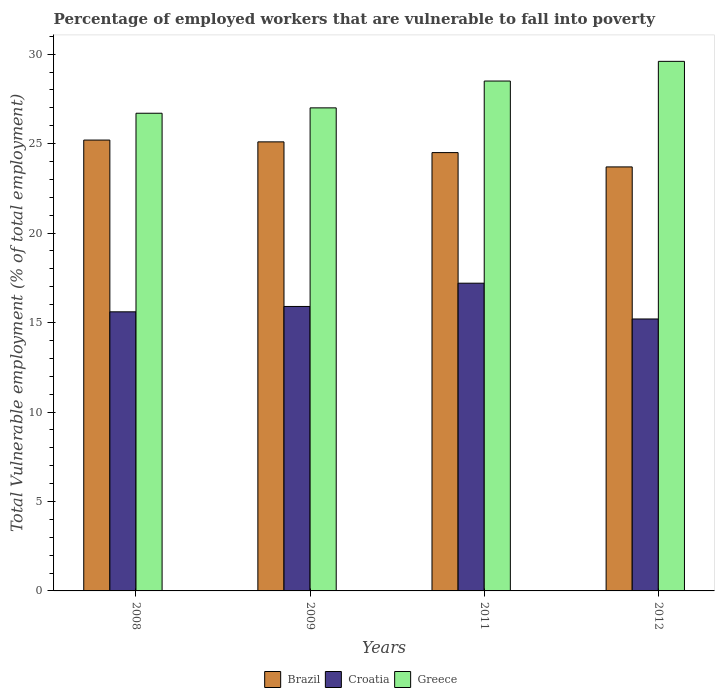How many different coloured bars are there?
Your answer should be very brief. 3. How many groups of bars are there?
Give a very brief answer. 4. How many bars are there on the 4th tick from the left?
Offer a terse response. 3. In how many cases, is the number of bars for a given year not equal to the number of legend labels?
Your answer should be compact. 0. What is the percentage of employed workers who are vulnerable to fall into poverty in Brazil in 2009?
Give a very brief answer. 25.1. Across all years, what is the maximum percentage of employed workers who are vulnerable to fall into poverty in Brazil?
Ensure brevity in your answer.  25.2. Across all years, what is the minimum percentage of employed workers who are vulnerable to fall into poverty in Greece?
Your answer should be very brief. 26.7. In which year was the percentage of employed workers who are vulnerable to fall into poverty in Greece maximum?
Ensure brevity in your answer.  2012. In which year was the percentage of employed workers who are vulnerable to fall into poverty in Croatia minimum?
Offer a very short reply. 2012. What is the total percentage of employed workers who are vulnerable to fall into poverty in Brazil in the graph?
Ensure brevity in your answer.  98.5. What is the difference between the percentage of employed workers who are vulnerable to fall into poverty in Greece in 2011 and that in 2012?
Your response must be concise. -1.1. What is the average percentage of employed workers who are vulnerable to fall into poverty in Croatia per year?
Your response must be concise. 15.98. In the year 2012, what is the difference between the percentage of employed workers who are vulnerable to fall into poverty in Brazil and percentage of employed workers who are vulnerable to fall into poverty in Croatia?
Your answer should be compact. 8.5. What is the ratio of the percentage of employed workers who are vulnerable to fall into poverty in Brazil in 2011 to that in 2012?
Make the answer very short. 1.03. What is the difference between the highest and the second highest percentage of employed workers who are vulnerable to fall into poverty in Brazil?
Provide a succinct answer. 0.1. What is the difference between the highest and the lowest percentage of employed workers who are vulnerable to fall into poverty in Croatia?
Offer a very short reply. 2. In how many years, is the percentage of employed workers who are vulnerable to fall into poverty in Greece greater than the average percentage of employed workers who are vulnerable to fall into poverty in Greece taken over all years?
Provide a succinct answer. 2. Is the sum of the percentage of employed workers who are vulnerable to fall into poverty in Croatia in 2008 and 2012 greater than the maximum percentage of employed workers who are vulnerable to fall into poverty in Brazil across all years?
Offer a terse response. Yes. What does the 1st bar from the left in 2008 represents?
Keep it short and to the point. Brazil. What does the 2nd bar from the right in 2008 represents?
Give a very brief answer. Croatia. Is it the case that in every year, the sum of the percentage of employed workers who are vulnerable to fall into poverty in Greece and percentage of employed workers who are vulnerable to fall into poverty in Brazil is greater than the percentage of employed workers who are vulnerable to fall into poverty in Croatia?
Provide a short and direct response. Yes. How many bars are there?
Make the answer very short. 12. How many years are there in the graph?
Give a very brief answer. 4. How many legend labels are there?
Provide a succinct answer. 3. What is the title of the graph?
Keep it short and to the point. Percentage of employed workers that are vulnerable to fall into poverty. Does "Morocco" appear as one of the legend labels in the graph?
Your response must be concise. No. What is the label or title of the X-axis?
Offer a terse response. Years. What is the label or title of the Y-axis?
Your answer should be very brief. Total Vulnerable employment (% of total employment). What is the Total Vulnerable employment (% of total employment) in Brazil in 2008?
Keep it short and to the point. 25.2. What is the Total Vulnerable employment (% of total employment) in Croatia in 2008?
Ensure brevity in your answer.  15.6. What is the Total Vulnerable employment (% of total employment) in Greece in 2008?
Provide a succinct answer. 26.7. What is the Total Vulnerable employment (% of total employment) of Brazil in 2009?
Keep it short and to the point. 25.1. What is the Total Vulnerable employment (% of total employment) of Croatia in 2009?
Offer a terse response. 15.9. What is the Total Vulnerable employment (% of total employment) of Greece in 2009?
Give a very brief answer. 27. What is the Total Vulnerable employment (% of total employment) of Croatia in 2011?
Your answer should be very brief. 17.2. What is the Total Vulnerable employment (% of total employment) in Brazil in 2012?
Your answer should be compact. 23.7. What is the Total Vulnerable employment (% of total employment) of Croatia in 2012?
Your response must be concise. 15.2. What is the Total Vulnerable employment (% of total employment) of Greece in 2012?
Offer a very short reply. 29.6. Across all years, what is the maximum Total Vulnerable employment (% of total employment) of Brazil?
Provide a short and direct response. 25.2. Across all years, what is the maximum Total Vulnerable employment (% of total employment) of Croatia?
Your answer should be compact. 17.2. Across all years, what is the maximum Total Vulnerable employment (% of total employment) of Greece?
Give a very brief answer. 29.6. Across all years, what is the minimum Total Vulnerable employment (% of total employment) of Brazil?
Provide a succinct answer. 23.7. Across all years, what is the minimum Total Vulnerable employment (% of total employment) of Croatia?
Your response must be concise. 15.2. Across all years, what is the minimum Total Vulnerable employment (% of total employment) in Greece?
Offer a very short reply. 26.7. What is the total Total Vulnerable employment (% of total employment) of Brazil in the graph?
Offer a terse response. 98.5. What is the total Total Vulnerable employment (% of total employment) of Croatia in the graph?
Provide a succinct answer. 63.9. What is the total Total Vulnerable employment (% of total employment) of Greece in the graph?
Offer a very short reply. 111.8. What is the difference between the Total Vulnerable employment (% of total employment) of Croatia in 2008 and that in 2009?
Provide a short and direct response. -0.3. What is the difference between the Total Vulnerable employment (% of total employment) of Greece in 2008 and that in 2009?
Give a very brief answer. -0.3. What is the difference between the Total Vulnerable employment (% of total employment) of Brazil in 2008 and that in 2011?
Your answer should be compact. 0.7. What is the difference between the Total Vulnerable employment (% of total employment) in Greece in 2008 and that in 2011?
Provide a short and direct response. -1.8. What is the difference between the Total Vulnerable employment (% of total employment) of Croatia in 2008 and that in 2012?
Keep it short and to the point. 0.4. What is the difference between the Total Vulnerable employment (% of total employment) of Brazil in 2009 and that in 2012?
Provide a succinct answer. 1.4. What is the difference between the Total Vulnerable employment (% of total employment) of Greece in 2011 and that in 2012?
Your answer should be compact. -1.1. What is the difference between the Total Vulnerable employment (% of total employment) in Brazil in 2008 and the Total Vulnerable employment (% of total employment) in Croatia in 2009?
Your answer should be compact. 9.3. What is the difference between the Total Vulnerable employment (% of total employment) of Croatia in 2008 and the Total Vulnerable employment (% of total employment) of Greece in 2009?
Provide a succinct answer. -11.4. What is the difference between the Total Vulnerable employment (% of total employment) of Brazil in 2008 and the Total Vulnerable employment (% of total employment) of Croatia in 2011?
Provide a short and direct response. 8. What is the difference between the Total Vulnerable employment (% of total employment) of Brazil in 2008 and the Total Vulnerable employment (% of total employment) of Greece in 2011?
Provide a short and direct response. -3.3. What is the difference between the Total Vulnerable employment (% of total employment) in Brazil in 2008 and the Total Vulnerable employment (% of total employment) in Greece in 2012?
Give a very brief answer. -4.4. What is the difference between the Total Vulnerable employment (% of total employment) of Brazil in 2009 and the Total Vulnerable employment (% of total employment) of Greece in 2011?
Offer a terse response. -3.4. What is the difference between the Total Vulnerable employment (% of total employment) of Brazil in 2009 and the Total Vulnerable employment (% of total employment) of Greece in 2012?
Make the answer very short. -4.5. What is the difference between the Total Vulnerable employment (% of total employment) in Croatia in 2009 and the Total Vulnerable employment (% of total employment) in Greece in 2012?
Provide a short and direct response. -13.7. What is the difference between the Total Vulnerable employment (% of total employment) of Brazil in 2011 and the Total Vulnerable employment (% of total employment) of Greece in 2012?
Your response must be concise. -5.1. What is the difference between the Total Vulnerable employment (% of total employment) in Croatia in 2011 and the Total Vulnerable employment (% of total employment) in Greece in 2012?
Your answer should be very brief. -12.4. What is the average Total Vulnerable employment (% of total employment) of Brazil per year?
Offer a terse response. 24.62. What is the average Total Vulnerable employment (% of total employment) of Croatia per year?
Your answer should be very brief. 15.97. What is the average Total Vulnerable employment (% of total employment) of Greece per year?
Your answer should be compact. 27.95. In the year 2008, what is the difference between the Total Vulnerable employment (% of total employment) of Brazil and Total Vulnerable employment (% of total employment) of Croatia?
Provide a short and direct response. 9.6. In the year 2008, what is the difference between the Total Vulnerable employment (% of total employment) in Croatia and Total Vulnerable employment (% of total employment) in Greece?
Make the answer very short. -11.1. In the year 2009, what is the difference between the Total Vulnerable employment (% of total employment) of Brazil and Total Vulnerable employment (% of total employment) of Croatia?
Offer a very short reply. 9.2. In the year 2011, what is the difference between the Total Vulnerable employment (% of total employment) in Brazil and Total Vulnerable employment (% of total employment) in Croatia?
Your response must be concise. 7.3. In the year 2011, what is the difference between the Total Vulnerable employment (% of total employment) of Brazil and Total Vulnerable employment (% of total employment) of Greece?
Your answer should be compact. -4. In the year 2011, what is the difference between the Total Vulnerable employment (% of total employment) of Croatia and Total Vulnerable employment (% of total employment) of Greece?
Make the answer very short. -11.3. In the year 2012, what is the difference between the Total Vulnerable employment (% of total employment) in Brazil and Total Vulnerable employment (% of total employment) in Greece?
Ensure brevity in your answer.  -5.9. In the year 2012, what is the difference between the Total Vulnerable employment (% of total employment) of Croatia and Total Vulnerable employment (% of total employment) of Greece?
Your answer should be compact. -14.4. What is the ratio of the Total Vulnerable employment (% of total employment) in Brazil in 2008 to that in 2009?
Ensure brevity in your answer.  1. What is the ratio of the Total Vulnerable employment (% of total employment) of Croatia in 2008 to that in 2009?
Your answer should be compact. 0.98. What is the ratio of the Total Vulnerable employment (% of total employment) in Greece in 2008 to that in 2009?
Offer a terse response. 0.99. What is the ratio of the Total Vulnerable employment (% of total employment) of Brazil in 2008 to that in 2011?
Offer a terse response. 1.03. What is the ratio of the Total Vulnerable employment (% of total employment) of Croatia in 2008 to that in 2011?
Offer a terse response. 0.91. What is the ratio of the Total Vulnerable employment (% of total employment) of Greece in 2008 to that in 2011?
Make the answer very short. 0.94. What is the ratio of the Total Vulnerable employment (% of total employment) of Brazil in 2008 to that in 2012?
Keep it short and to the point. 1.06. What is the ratio of the Total Vulnerable employment (% of total employment) in Croatia in 2008 to that in 2012?
Offer a terse response. 1.03. What is the ratio of the Total Vulnerable employment (% of total employment) of Greece in 2008 to that in 2012?
Offer a very short reply. 0.9. What is the ratio of the Total Vulnerable employment (% of total employment) in Brazil in 2009 to that in 2011?
Give a very brief answer. 1.02. What is the ratio of the Total Vulnerable employment (% of total employment) in Croatia in 2009 to that in 2011?
Give a very brief answer. 0.92. What is the ratio of the Total Vulnerable employment (% of total employment) in Greece in 2009 to that in 2011?
Provide a succinct answer. 0.95. What is the ratio of the Total Vulnerable employment (% of total employment) in Brazil in 2009 to that in 2012?
Your answer should be compact. 1.06. What is the ratio of the Total Vulnerable employment (% of total employment) in Croatia in 2009 to that in 2012?
Provide a short and direct response. 1.05. What is the ratio of the Total Vulnerable employment (% of total employment) in Greece in 2009 to that in 2012?
Offer a very short reply. 0.91. What is the ratio of the Total Vulnerable employment (% of total employment) of Brazil in 2011 to that in 2012?
Ensure brevity in your answer.  1.03. What is the ratio of the Total Vulnerable employment (% of total employment) in Croatia in 2011 to that in 2012?
Offer a very short reply. 1.13. What is the ratio of the Total Vulnerable employment (% of total employment) of Greece in 2011 to that in 2012?
Give a very brief answer. 0.96. What is the difference between the highest and the second highest Total Vulnerable employment (% of total employment) in Brazil?
Ensure brevity in your answer.  0.1. What is the difference between the highest and the second highest Total Vulnerable employment (% of total employment) in Croatia?
Ensure brevity in your answer.  1.3. What is the difference between the highest and the second highest Total Vulnerable employment (% of total employment) in Greece?
Offer a terse response. 1.1. What is the difference between the highest and the lowest Total Vulnerable employment (% of total employment) of Brazil?
Give a very brief answer. 1.5. 